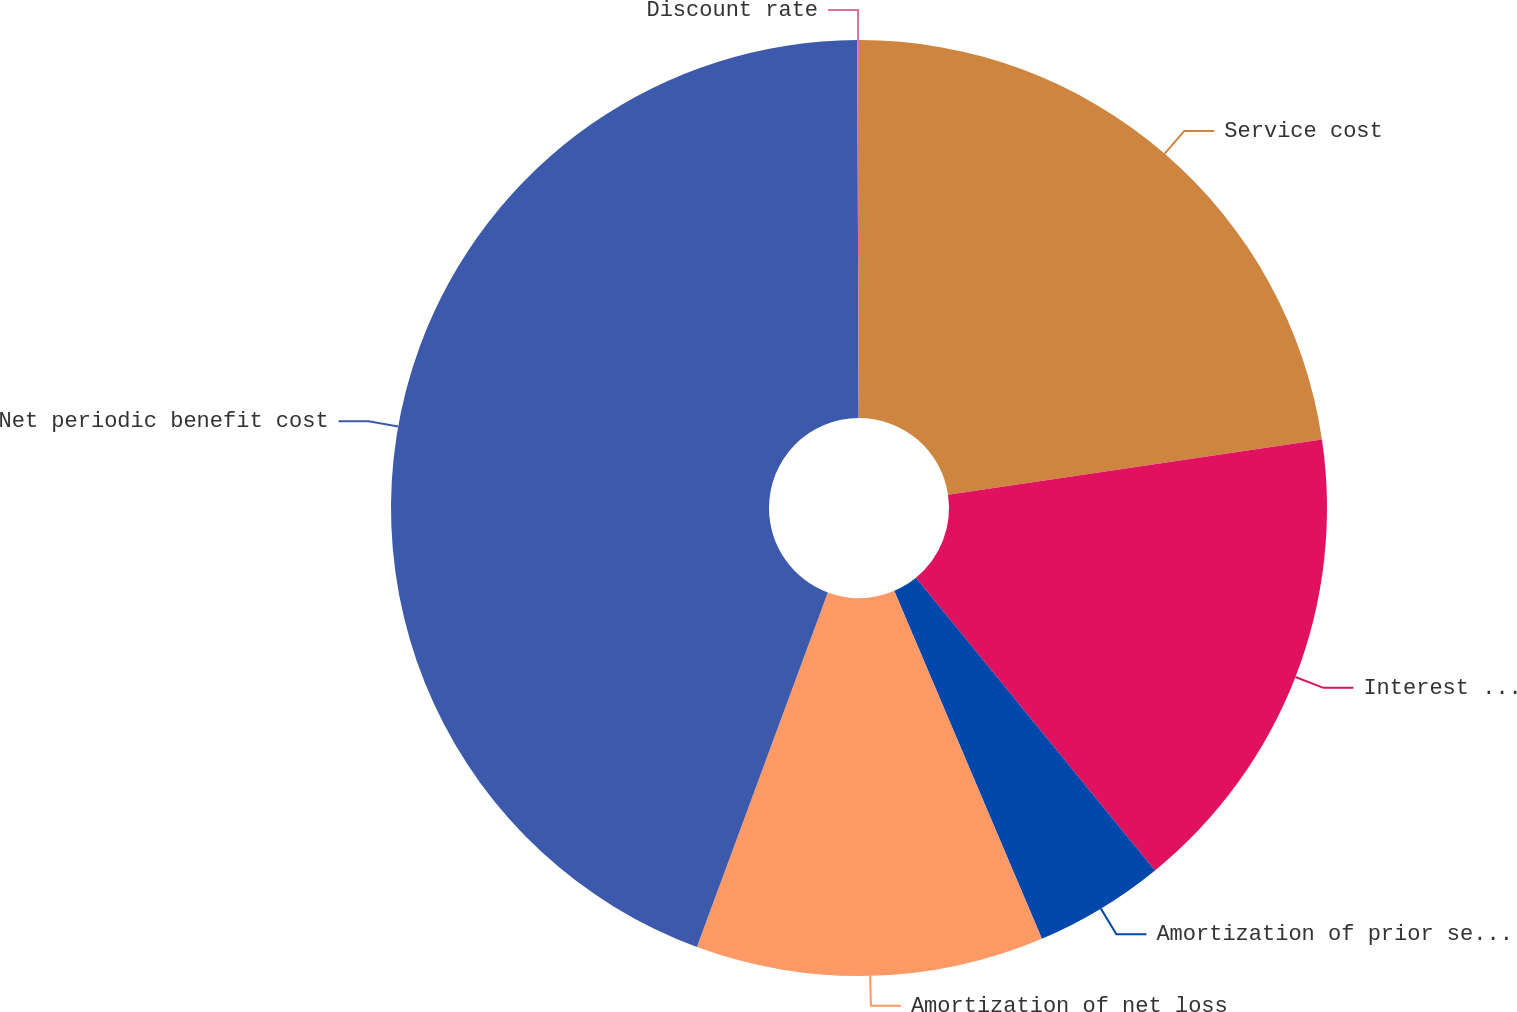Convert chart. <chart><loc_0><loc_0><loc_500><loc_500><pie_chart><fcel>Service cost<fcel>Interest cost<fcel>Amortization of prior service<fcel>Amortization of net loss<fcel>Net periodic benefit cost<fcel>Discount rate<nl><fcel>22.66%<fcel>16.44%<fcel>4.51%<fcel>12.02%<fcel>44.31%<fcel>0.06%<nl></chart> 